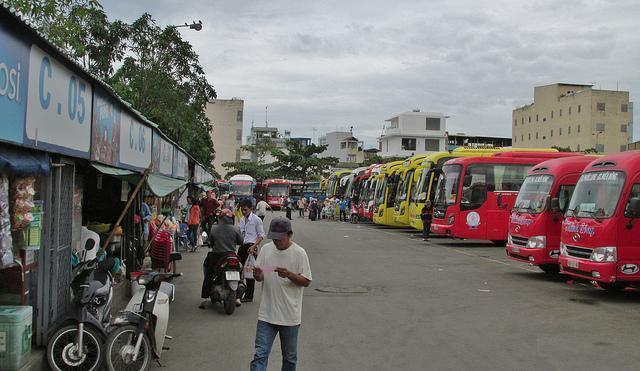How many motorbikes are there?
Give a very brief answer. 3. How many yellow buses are there?
Give a very brief answer. 3. How many motorcycles are there?
Give a very brief answer. 3. How many motorcycles can you see?
Give a very brief answer. 2. How many buses can be seen?
Give a very brief answer. 4. 